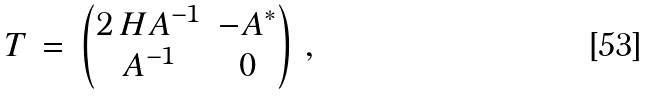<formula> <loc_0><loc_0><loc_500><loc_500>T \, = \, \begin{pmatrix} 2 \, H A ^ { - 1 } & - A ^ { * } \\ A ^ { - 1 } & 0 \end{pmatrix} \, ,</formula> 